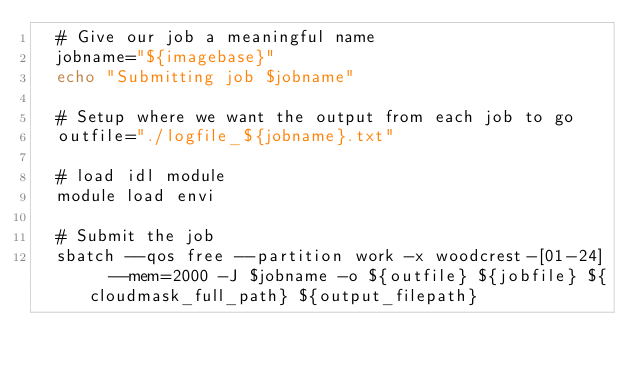Convert code to text. <code><loc_0><loc_0><loc_500><loc_500><_Bash_>  # Give our job a meaningful name
  jobname="${imagebase}"
  echo "Submitting job $jobname"
 
  # Setup where we want the output from each job to go
  outfile="./logfile_${jobname}.txt"
    
  # load idl module
  module load envi

  # Submit the job
  sbatch --qos free --partition work -x woodcrest-[01-24]  --mem=2000 -J $jobname -o ${outfile} ${jobfile} ${cloudmask_full_path} ${output_filepath}
</code> 